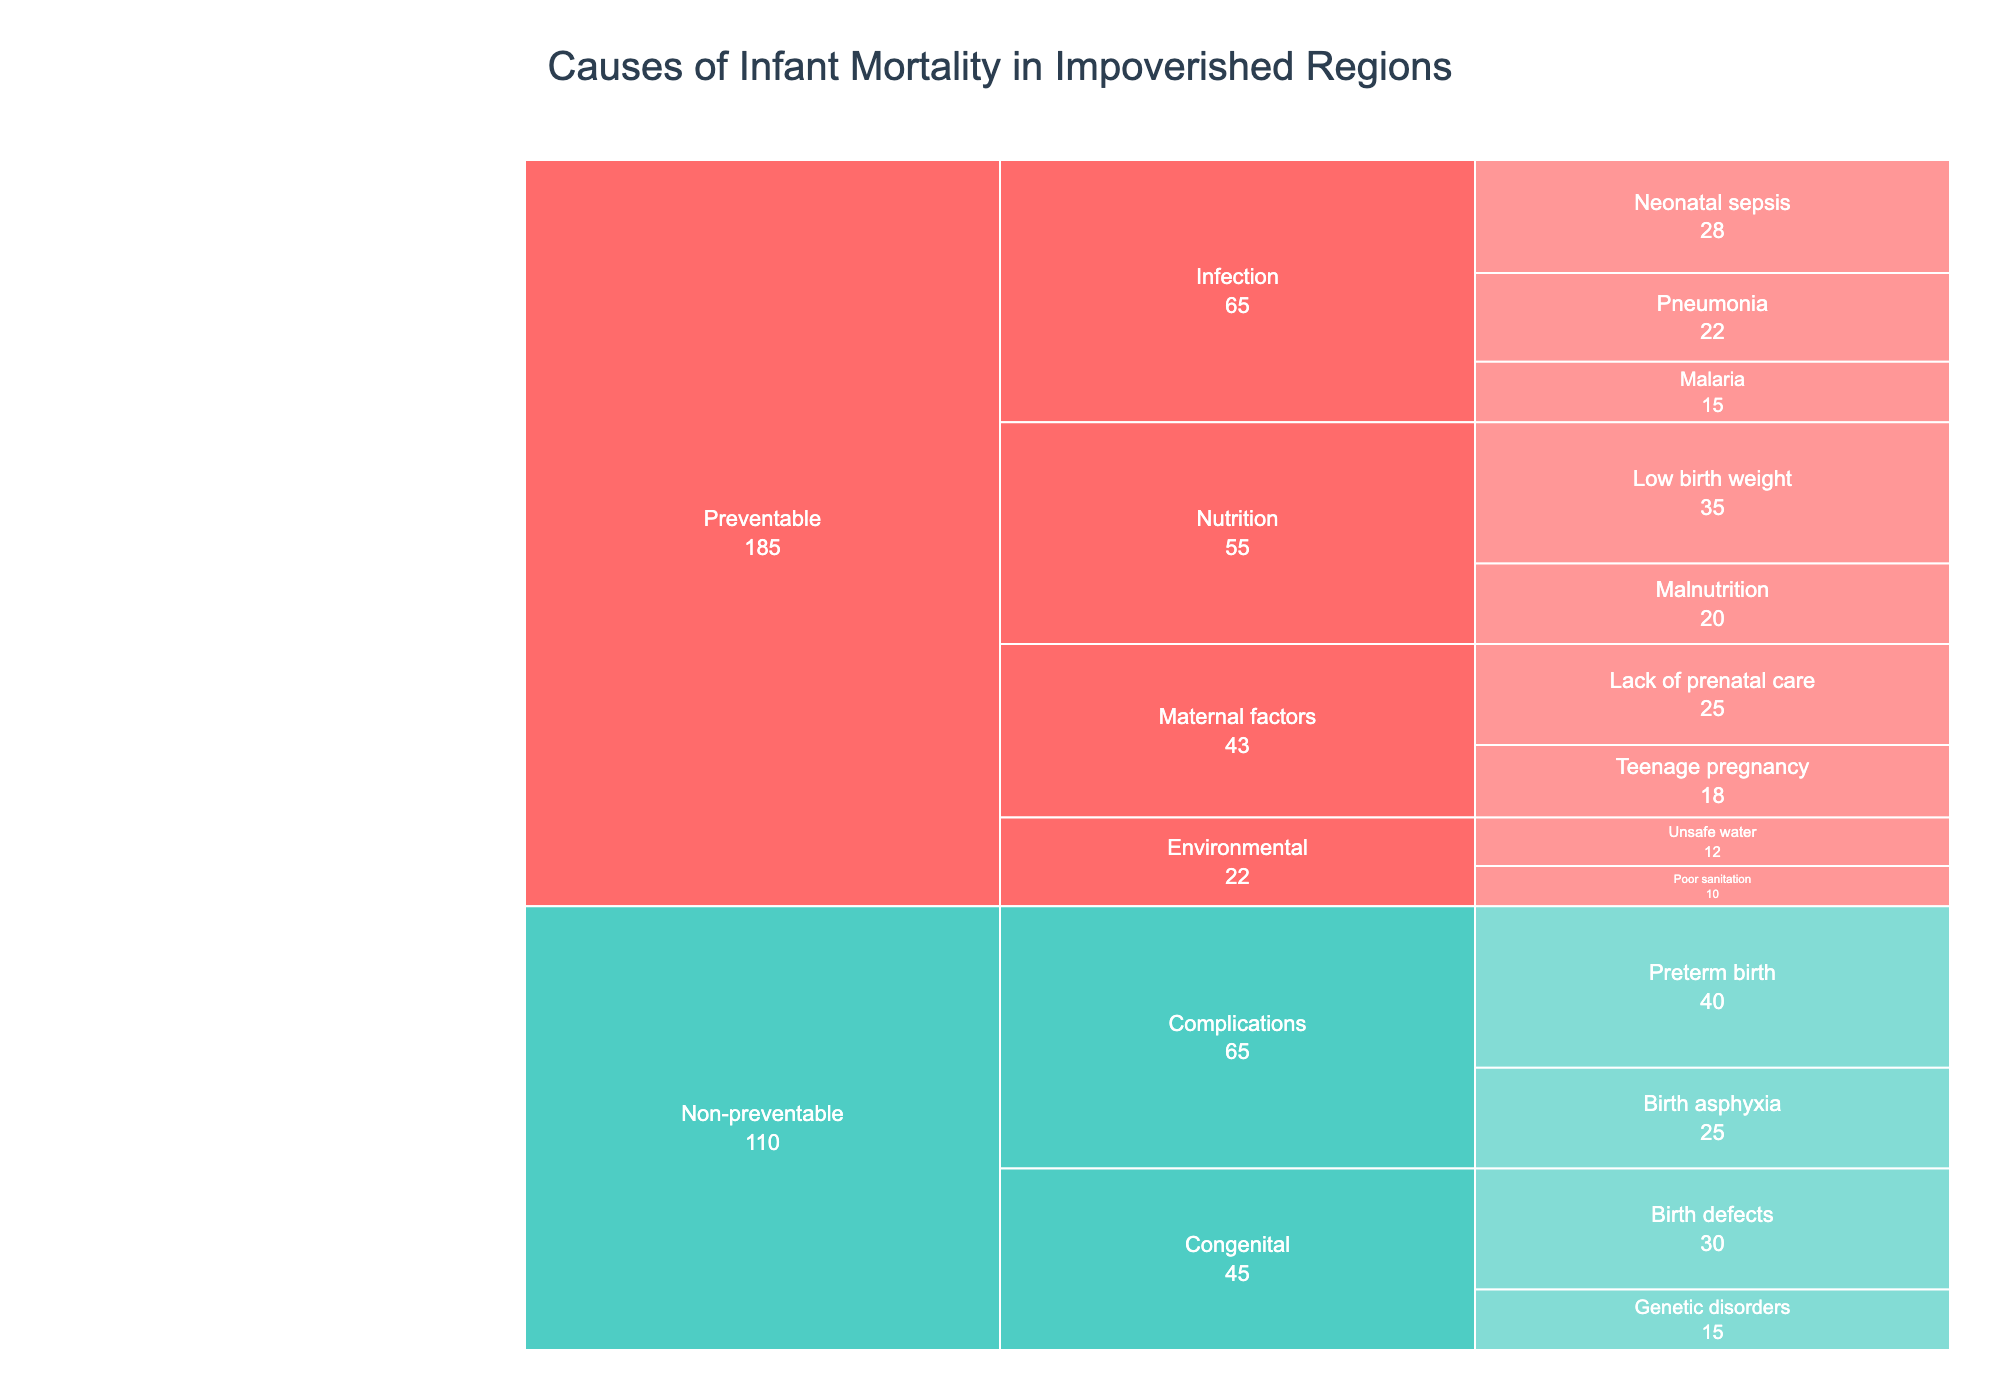What's the title of the Icicle Chart? The title of a chart is usually displayed at the top in a larger font size than the rest of the text. In this case, the title is given directly in the data and code.
Answer: Causes of Infant Mortality in Impoverished Regions What are the two main categories of causes of infant mortality shown in the chart? The Icicle Chart segments data into hierarchical layers, with the highest level categories displayed first. The dataset clearly divides the causes into two categories.
Answer: Preventable and Non-preventable Which subcategory under Preventable factors has the highest value and what is that value? Locate the segment labeled under Preventable that represents the largest portion of the chart. The values are explicitly shown in the Icicle Chart, so the largest value in the Preventable category can be easily identified.
Answer: Nutrition, 35 What are the two causes with the lowest values in the Preventable category? By visually scanning the segments under Preventable, one can identify the smallest segments representing the lowest values. These values are directly labeled.
Answer: Malnutrition and Poor sanitation How does the value of Preterm birth compare to the value of Neonatal sepsis? Locate both Preterm birth and Neonatal sepsis in their respective segments. Check their labels for values and compare these numerically.
Answer: Preterm birth (40) is higher than Neonatal sepsis (28) Sum up the values of all preventable factors. Identify and sum the values under the Preventable category: (28+22+15+35+20+25+18+12+10). Perform the arithmetic calculation.
Answer: 185 Which subcategory under Non-preventable factors contributes the most to infant mortality? The largest segment within the Non-preventable category directly indicates the subcategory that contributes the most. Identify it by its area and value.
Answer: Complications Compare the total values of Preventable and Non-preventable categories. Which category has a higher total value? Sum up all values in each category and compare the totals: (Preventable: 185) vs (Non-preventable: 30+15+40+25). Calculate these sums and compare.
Answer: Preventable (185) is higher What is the combined value of Birth defects and Genetic disorders? Locate both Birth defects and Genetic disorders in the chart under Non-preventable, add their values together: (30+15).
Answer: 45 What percentage of infant mortality is due to Preventable Nutrition factors? Sum the Preventable Nutrition values: (35+20), then divide by the total Preventable value (185) and multiply by 100 to get the percentage.
Answer: (55/185) * 100 = 29.7% 